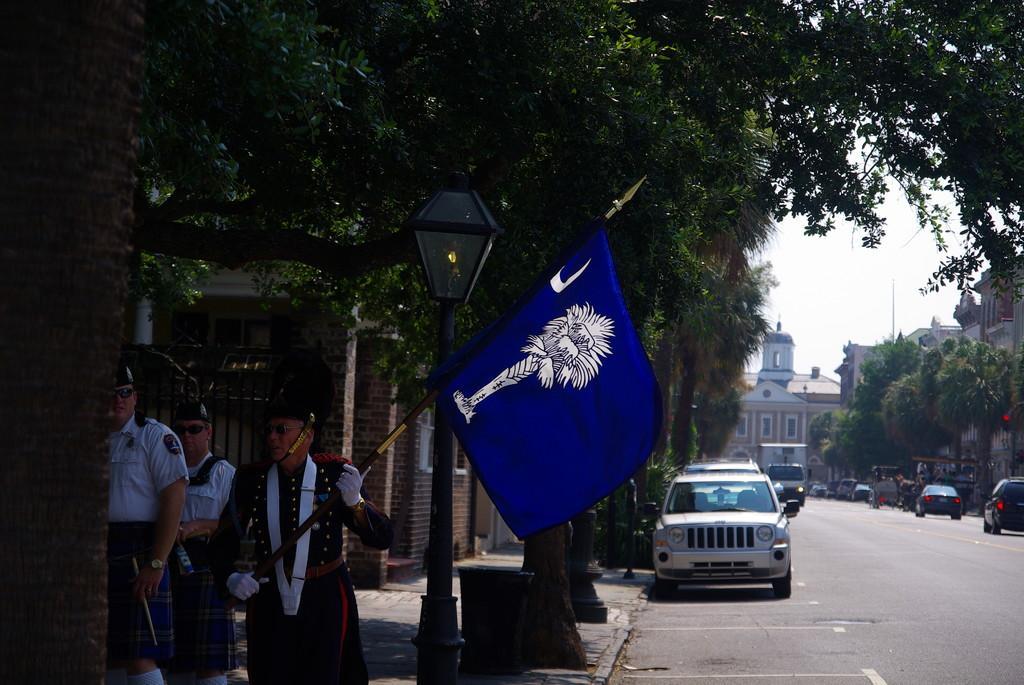Please provide a concise description of this image. In this image there is the sky, there are buildings truncated towards the right of the image, there are trees truncated towards the right of the image, there is road, there are vehicles on the road, there is a car truncated towards the right of the image, there is a pole, there is a streetlight, there are three persons, there are persons holding objects, there is a flag, there are objects on the ground, there are trees truncated at the top of the image, there is a wall truncated towards the left of the image. 